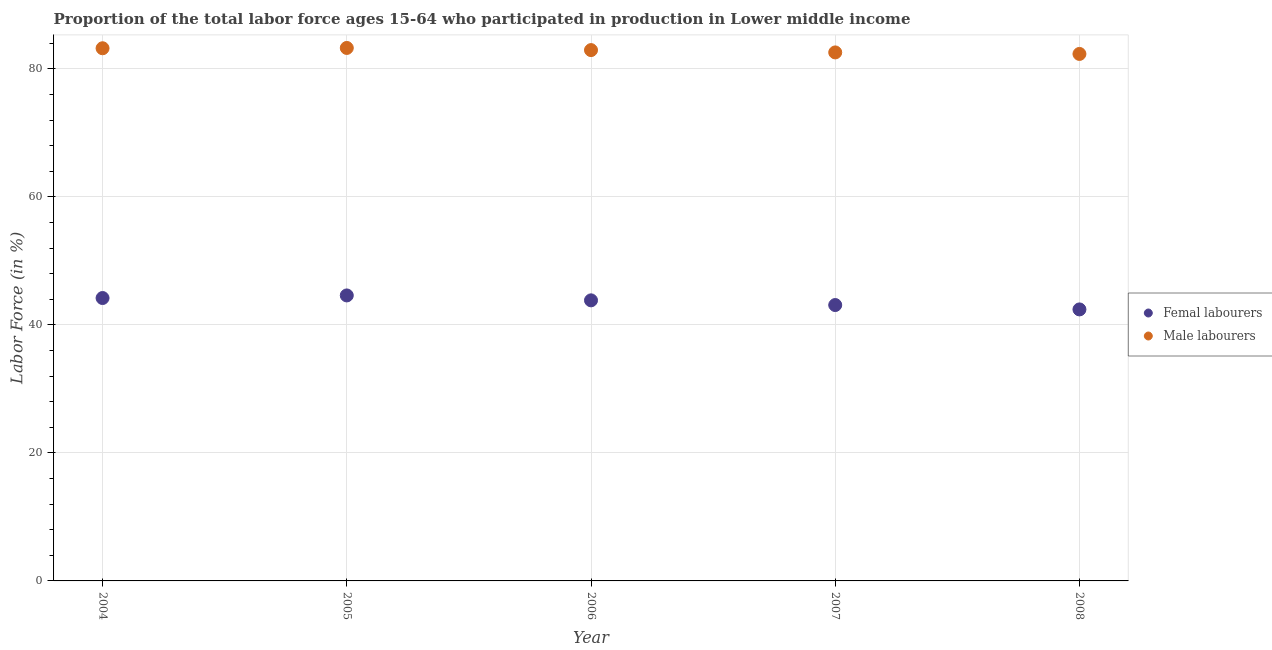What is the percentage of female labor force in 2008?
Keep it short and to the point. 42.41. Across all years, what is the maximum percentage of male labour force?
Your answer should be very brief. 83.26. Across all years, what is the minimum percentage of female labor force?
Ensure brevity in your answer.  42.41. In which year was the percentage of female labor force minimum?
Offer a terse response. 2008. What is the total percentage of female labor force in the graph?
Offer a very short reply. 218.12. What is the difference between the percentage of female labor force in 2005 and that in 2006?
Your answer should be very brief. 0.77. What is the difference between the percentage of female labor force in 2005 and the percentage of male labour force in 2004?
Give a very brief answer. -38.61. What is the average percentage of female labor force per year?
Your answer should be compact. 43.62. In the year 2006, what is the difference between the percentage of male labour force and percentage of female labor force?
Make the answer very short. 39.09. In how many years, is the percentage of male labour force greater than 8 %?
Your response must be concise. 5. What is the ratio of the percentage of female labor force in 2005 to that in 2006?
Ensure brevity in your answer.  1.02. Is the percentage of female labor force in 2006 less than that in 2008?
Keep it short and to the point. No. What is the difference between the highest and the second highest percentage of female labor force?
Provide a succinct answer. 0.4. What is the difference between the highest and the lowest percentage of male labour force?
Give a very brief answer. 0.94. Is the percentage of male labour force strictly greater than the percentage of female labor force over the years?
Your response must be concise. Yes. Is the percentage of female labor force strictly less than the percentage of male labour force over the years?
Your answer should be very brief. Yes. How many dotlines are there?
Keep it short and to the point. 2. What is the difference between two consecutive major ticks on the Y-axis?
Provide a succinct answer. 20. Where does the legend appear in the graph?
Offer a very short reply. Center right. How many legend labels are there?
Provide a succinct answer. 2. How are the legend labels stacked?
Your answer should be very brief. Vertical. What is the title of the graph?
Your answer should be very brief. Proportion of the total labor force ages 15-64 who participated in production in Lower middle income. What is the label or title of the X-axis?
Offer a very short reply. Year. What is the label or title of the Y-axis?
Offer a terse response. Labor Force (in %). What is the Labor Force (in %) of Femal labourers in 2004?
Offer a very short reply. 44.19. What is the Labor Force (in %) in Male labourers in 2004?
Make the answer very short. 83.21. What is the Labor Force (in %) of Femal labourers in 2005?
Your answer should be compact. 44.6. What is the Labor Force (in %) in Male labourers in 2005?
Your response must be concise. 83.26. What is the Labor Force (in %) of Femal labourers in 2006?
Give a very brief answer. 43.83. What is the Labor Force (in %) of Male labourers in 2006?
Keep it short and to the point. 82.92. What is the Labor Force (in %) of Femal labourers in 2007?
Give a very brief answer. 43.1. What is the Labor Force (in %) of Male labourers in 2007?
Give a very brief answer. 82.56. What is the Labor Force (in %) in Femal labourers in 2008?
Your response must be concise. 42.41. What is the Labor Force (in %) in Male labourers in 2008?
Ensure brevity in your answer.  82.32. Across all years, what is the maximum Labor Force (in %) of Femal labourers?
Offer a very short reply. 44.6. Across all years, what is the maximum Labor Force (in %) in Male labourers?
Provide a short and direct response. 83.26. Across all years, what is the minimum Labor Force (in %) of Femal labourers?
Your answer should be very brief. 42.41. Across all years, what is the minimum Labor Force (in %) of Male labourers?
Provide a succinct answer. 82.32. What is the total Labor Force (in %) in Femal labourers in the graph?
Provide a short and direct response. 218.12. What is the total Labor Force (in %) in Male labourers in the graph?
Give a very brief answer. 414.26. What is the difference between the Labor Force (in %) of Femal labourers in 2004 and that in 2005?
Your answer should be compact. -0.4. What is the difference between the Labor Force (in %) of Male labourers in 2004 and that in 2005?
Give a very brief answer. -0.05. What is the difference between the Labor Force (in %) in Femal labourers in 2004 and that in 2006?
Your answer should be very brief. 0.36. What is the difference between the Labor Force (in %) in Male labourers in 2004 and that in 2006?
Your answer should be very brief. 0.29. What is the difference between the Labor Force (in %) of Femal labourers in 2004 and that in 2007?
Offer a terse response. 1.1. What is the difference between the Labor Force (in %) of Male labourers in 2004 and that in 2007?
Offer a very short reply. 0.65. What is the difference between the Labor Force (in %) of Femal labourers in 2004 and that in 2008?
Offer a terse response. 1.78. What is the difference between the Labor Force (in %) in Male labourers in 2004 and that in 2008?
Offer a terse response. 0.89. What is the difference between the Labor Force (in %) in Femal labourers in 2005 and that in 2006?
Make the answer very short. 0.77. What is the difference between the Labor Force (in %) of Male labourers in 2005 and that in 2006?
Ensure brevity in your answer.  0.34. What is the difference between the Labor Force (in %) in Femal labourers in 2005 and that in 2007?
Make the answer very short. 1.5. What is the difference between the Labor Force (in %) in Male labourers in 2005 and that in 2007?
Provide a short and direct response. 0.7. What is the difference between the Labor Force (in %) in Femal labourers in 2005 and that in 2008?
Offer a terse response. 2.18. What is the difference between the Labor Force (in %) of Male labourers in 2005 and that in 2008?
Your response must be concise. 0.94. What is the difference between the Labor Force (in %) of Femal labourers in 2006 and that in 2007?
Make the answer very short. 0.73. What is the difference between the Labor Force (in %) in Male labourers in 2006 and that in 2007?
Provide a short and direct response. 0.36. What is the difference between the Labor Force (in %) in Femal labourers in 2006 and that in 2008?
Ensure brevity in your answer.  1.42. What is the difference between the Labor Force (in %) in Male labourers in 2006 and that in 2008?
Ensure brevity in your answer.  0.6. What is the difference between the Labor Force (in %) in Femal labourers in 2007 and that in 2008?
Your response must be concise. 0.68. What is the difference between the Labor Force (in %) in Male labourers in 2007 and that in 2008?
Offer a terse response. 0.24. What is the difference between the Labor Force (in %) in Femal labourers in 2004 and the Labor Force (in %) in Male labourers in 2005?
Your response must be concise. -39.06. What is the difference between the Labor Force (in %) of Femal labourers in 2004 and the Labor Force (in %) of Male labourers in 2006?
Your answer should be compact. -38.73. What is the difference between the Labor Force (in %) in Femal labourers in 2004 and the Labor Force (in %) in Male labourers in 2007?
Give a very brief answer. -38.37. What is the difference between the Labor Force (in %) in Femal labourers in 2004 and the Labor Force (in %) in Male labourers in 2008?
Offer a terse response. -38.13. What is the difference between the Labor Force (in %) of Femal labourers in 2005 and the Labor Force (in %) of Male labourers in 2006?
Make the answer very short. -38.32. What is the difference between the Labor Force (in %) in Femal labourers in 2005 and the Labor Force (in %) in Male labourers in 2007?
Ensure brevity in your answer.  -37.96. What is the difference between the Labor Force (in %) in Femal labourers in 2005 and the Labor Force (in %) in Male labourers in 2008?
Your answer should be compact. -37.72. What is the difference between the Labor Force (in %) in Femal labourers in 2006 and the Labor Force (in %) in Male labourers in 2007?
Your answer should be compact. -38.73. What is the difference between the Labor Force (in %) in Femal labourers in 2006 and the Labor Force (in %) in Male labourers in 2008?
Your answer should be very brief. -38.49. What is the difference between the Labor Force (in %) in Femal labourers in 2007 and the Labor Force (in %) in Male labourers in 2008?
Offer a terse response. -39.23. What is the average Labor Force (in %) in Femal labourers per year?
Offer a terse response. 43.62. What is the average Labor Force (in %) in Male labourers per year?
Ensure brevity in your answer.  82.85. In the year 2004, what is the difference between the Labor Force (in %) of Femal labourers and Labor Force (in %) of Male labourers?
Offer a terse response. -39.02. In the year 2005, what is the difference between the Labor Force (in %) in Femal labourers and Labor Force (in %) in Male labourers?
Give a very brief answer. -38.66. In the year 2006, what is the difference between the Labor Force (in %) in Femal labourers and Labor Force (in %) in Male labourers?
Offer a very short reply. -39.09. In the year 2007, what is the difference between the Labor Force (in %) in Femal labourers and Labor Force (in %) in Male labourers?
Offer a terse response. -39.46. In the year 2008, what is the difference between the Labor Force (in %) in Femal labourers and Labor Force (in %) in Male labourers?
Offer a very short reply. -39.91. What is the ratio of the Labor Force (in %) in Femal labourers in 2004 to that in 2005?
Give a very brief answer. 0.99. What is the ratio of the Labor Force (in %) of Male labourers in 2004 to that in 2005?
Provide a short and direct response. 1. What is the ratio of the Labor Force (in %) of Femal labourers in 2004 to that in 2006?
Make the answer very short. 1.01. What is the ratio of the Labor Force (in %) in Femal labourers in 2004 to that in 2007?
Provide a succinct answer. 1.03. What is the ratio of the Labor Force (in %) in Male labourers in 2004 to that in 2007?
Your answer should be compact. 1.01. What is the ratio of the Labor Force (in %) in Femal labourers in 2004 to that in 2008?
Your answer should be very brief. 1.04. What is the ratio of the Labor Force (in %) in Male labourers in 2004 to that in 2008?
Offer a very short reply. 1.01. What is the ratio of the Labor Force (in %) of Femal labourers in 2005 to that in 2006?
Make the answer very short. 1.02. What is the ratio of the Labor Force (in %) of Femal labourers in 2005 to that in 2007?
Ensure brevity in your answer.  1.03. What is the ratio of the Labor Force (in %) in Male labourers in 2005 to that in 2007?
Offer a very short reply. 1.01. What is the ratio of the Labor Force (in %) of Femal labourers in 2005 to that in 2008?
Provide a succinct answer. 1.05. What is the ratio of the Labor Force (in %) in Male labourers in 2005 to that in 2008?
Your response must be concise. 1.01. What is the ratio of the Labor Force (in %) in Male labourers in 2006 to that in 2007?
Provide a short and direct response. 1. What is the ratio of the Labor Force (in %) in Femal labourers in 2006 to that in 2008?
Offer a terse response. 1.03. What is the ratio of the Labor Force (in %) in Male labourers in 2006 to that in 2008?
Give a very brief answer. 1.01. What is the ratio of the Labor Force (in %) in Femal labourers in 2007 to that in 2008?
Offer a terse response. 1.02. What is the difference between the highest and the second highest Labor Force (in %) in Femal labourers?
Offer a very short reply. 0.4. What is the difference between the highest and the second highest Labor Force (in %) in Male labourers?
Ensure brevity in your answer.  0.05. What is the difference between the highest and the lowest Labor Force (in %) of Femal labourers?
Offer a very short reply. 2.18. What is the difference between the highest and the lowest Labor Force (in %) in Male labourers?
Offer a terse response. 0.94. 